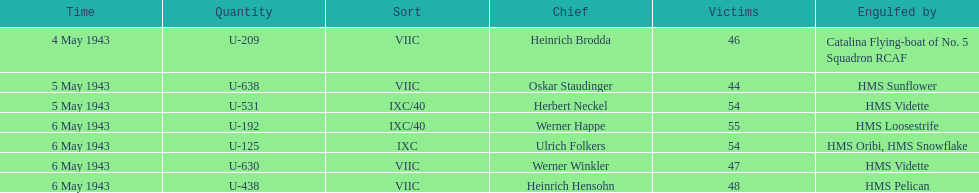Which sunken u-boat had the most casualties U-192. 